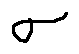<formula> <loc_0><loc_0><loc_500><loc_500>\sigma</formula> 